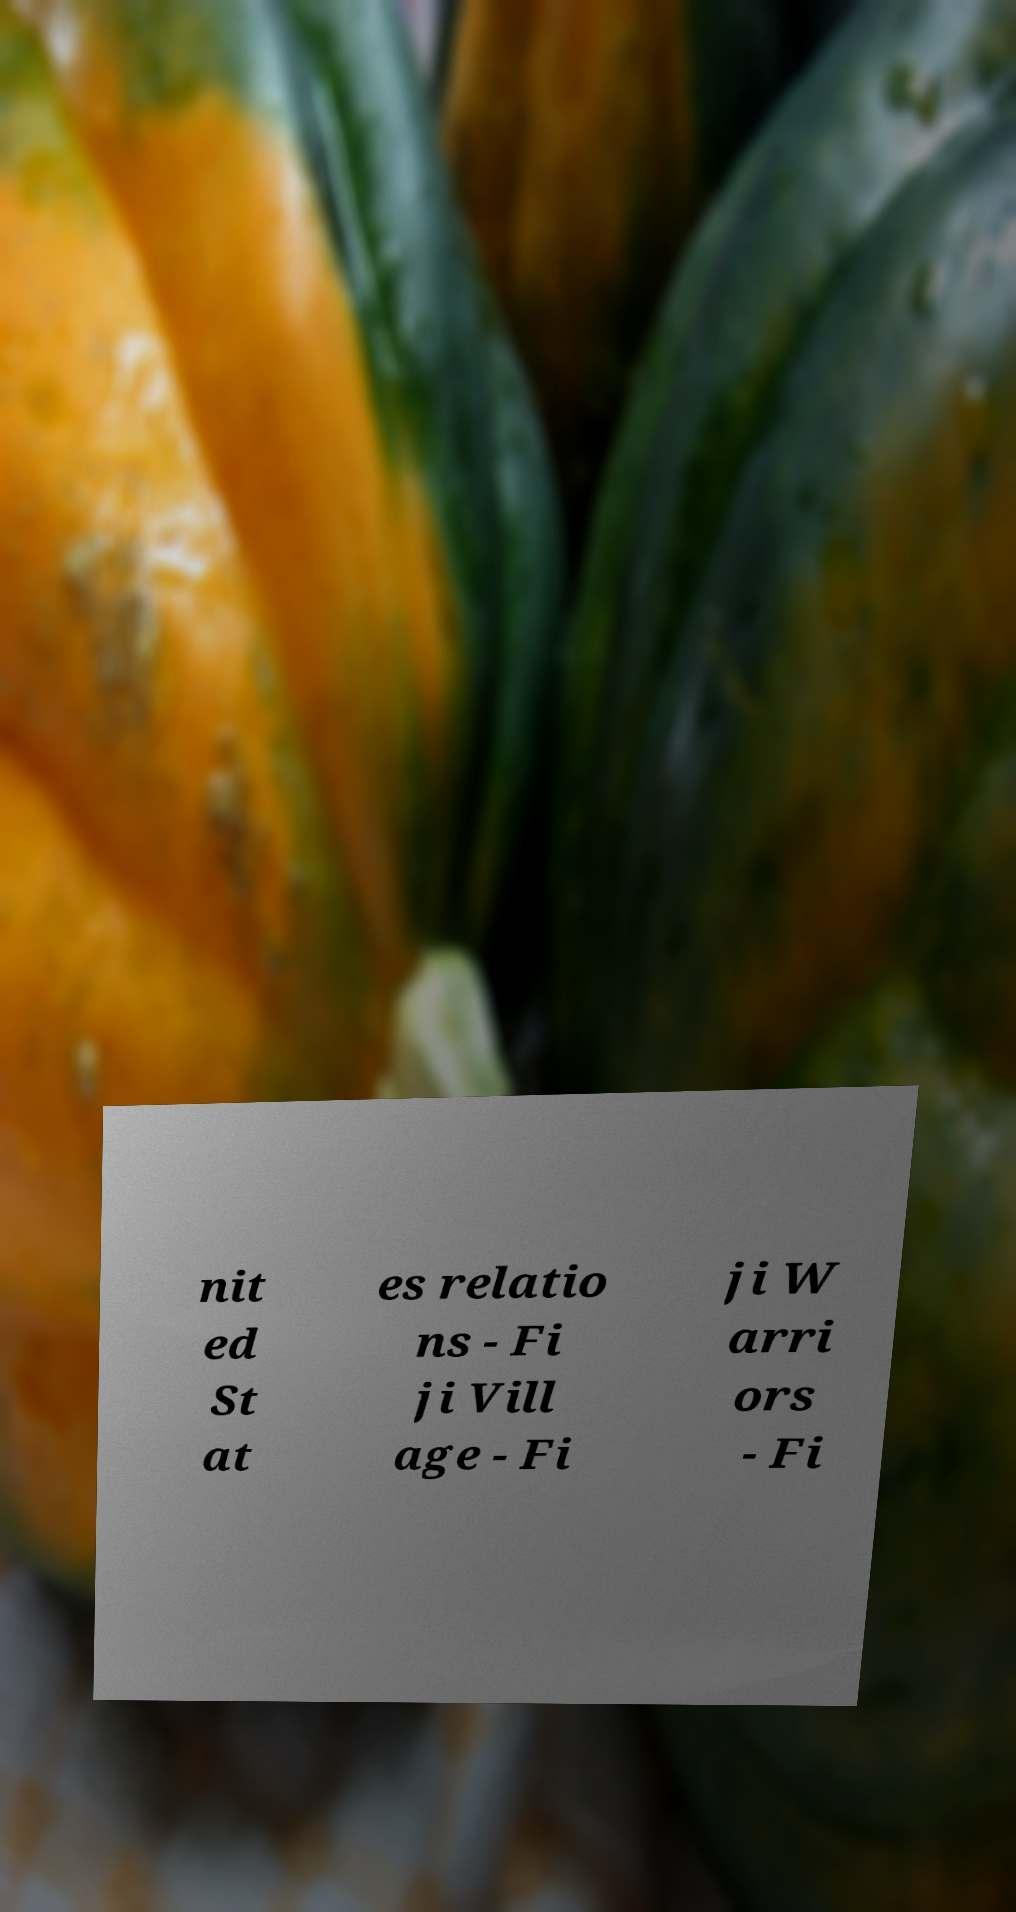Please read and relay the text visible in this image. What does it say? nit ed St at es relatio ns - Fi ji Vill age - Fi ji W arri ors - Fi 